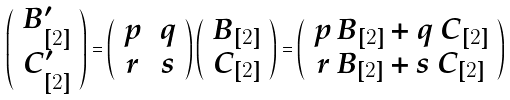<formula> <loc_0><loc_0><loc_500><loc_500>\left ( \begin{array} { c } B _ { [ 2 ] } ^ { \prime } \\ C _ { [ 2 ] } ^ { \prime } \end{array} \right ) = \left ( \begin{array} { c c } p & q \\ r & s \end{array} \right ) \left ( \begin{array} { c } B _ { [ 2 ] } \\ C _ { [ 2 ] } \end{array} \right ) = \left ( \begin{array} { c } p \, B _ { [ 2 ] } + q \, C _ { [ 2 ] } \\ r \, B _ { [ 2 ] } + s \, C _ { [ 2 ] } \end{array} \right )</formula> 